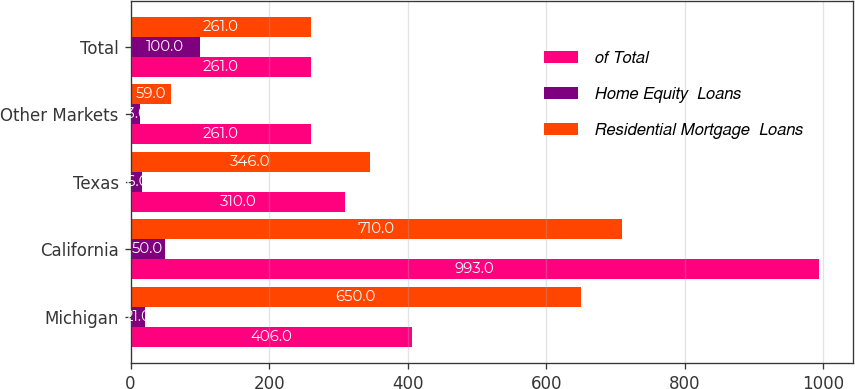Convert chart to OTSL. <chart><loc_0><loc_0><loc_500><loc_500><stacked_bar_chart><ecel><fcel>Michigan<fcel>California<fcel>Texas<fcel>Other Markets<fcel>Total<nl><fcel>of Total<fcel>406<fcel>993<fcel>310<fcel>261<fcel>261<nl><fcel>Home Equity  Loans<fcel>21<fcel>50<fcel>16<fcel>13<fcel>100<nl><fcel>Residential Mortgage  Loans<fcel>650<fcel>710<fcel>346<fcel>59<fcel>261<nl></chart> 